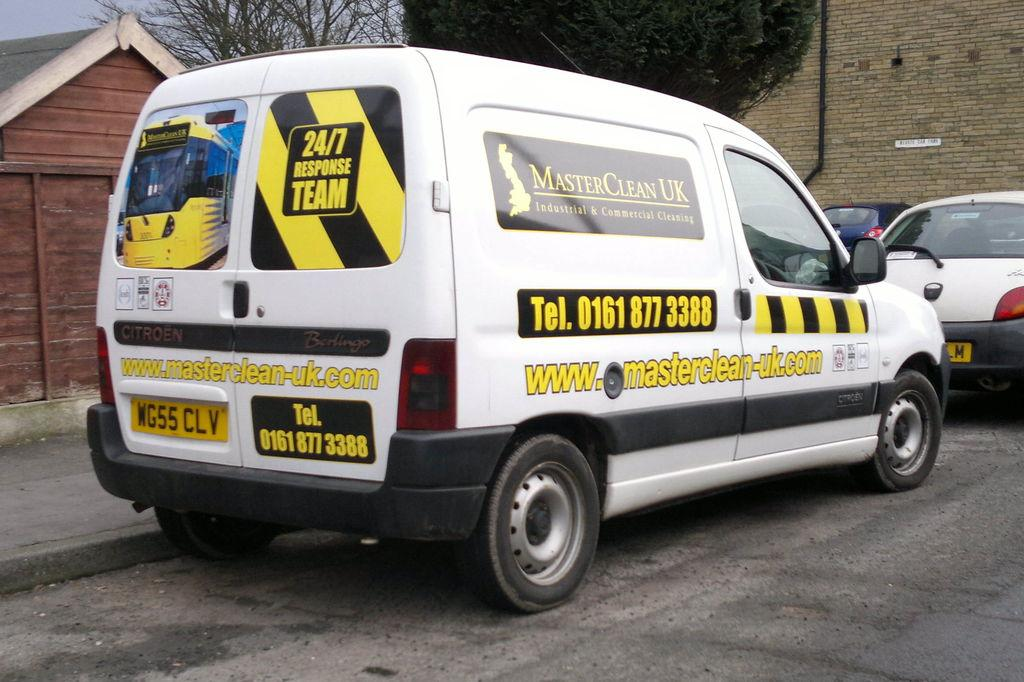Provide a one-sentence caption for the provided image. A white van that says Master Clean UK on it. 